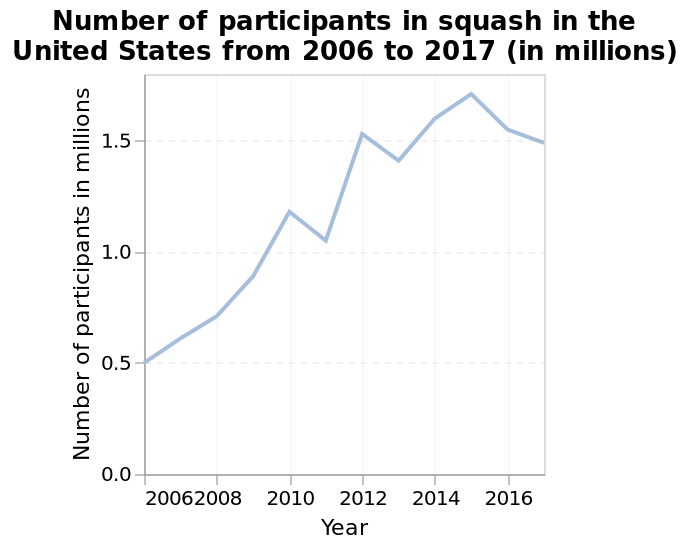<image>
What is the minimum number of participants in squash in the United States during the given time period? The minimum number of participants in squash in the United States during the given time period is not mentioned in the description. Offer a thorough analysis of the image. Squash seems to be increasing in popularity in the states over the years represented on the graph. Does squash seem to be decreasing in popularity in the states over the years represented on the graph? No.Squash seems to be increasing in popularity in the states over the years represented on the graph. 